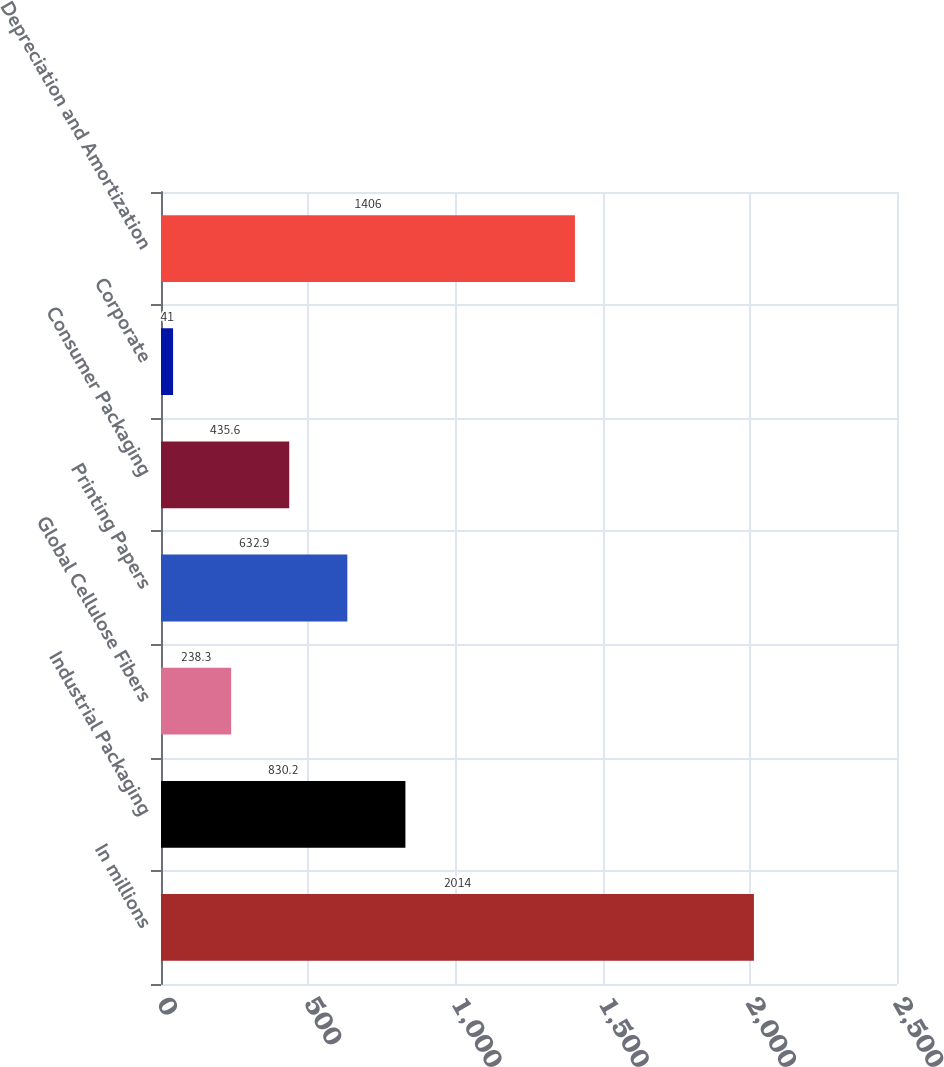<chart> <loc_0><loc_0><loc_500><loc_500><bar_chart><fcel>In millions<fcel>Industrial Packaging<fcel>Global Cellulose Fibers<fcel>Printing Papers<fcel>Consumer Packaging<fcel>Corporate<fcel>Depreciation and Amortization<nl><fcel>2014<fcel>830.2<fcel>238.3<fcel>632.9<fcel>435.6<fcel>41<fcel>1406<nl></chart> 